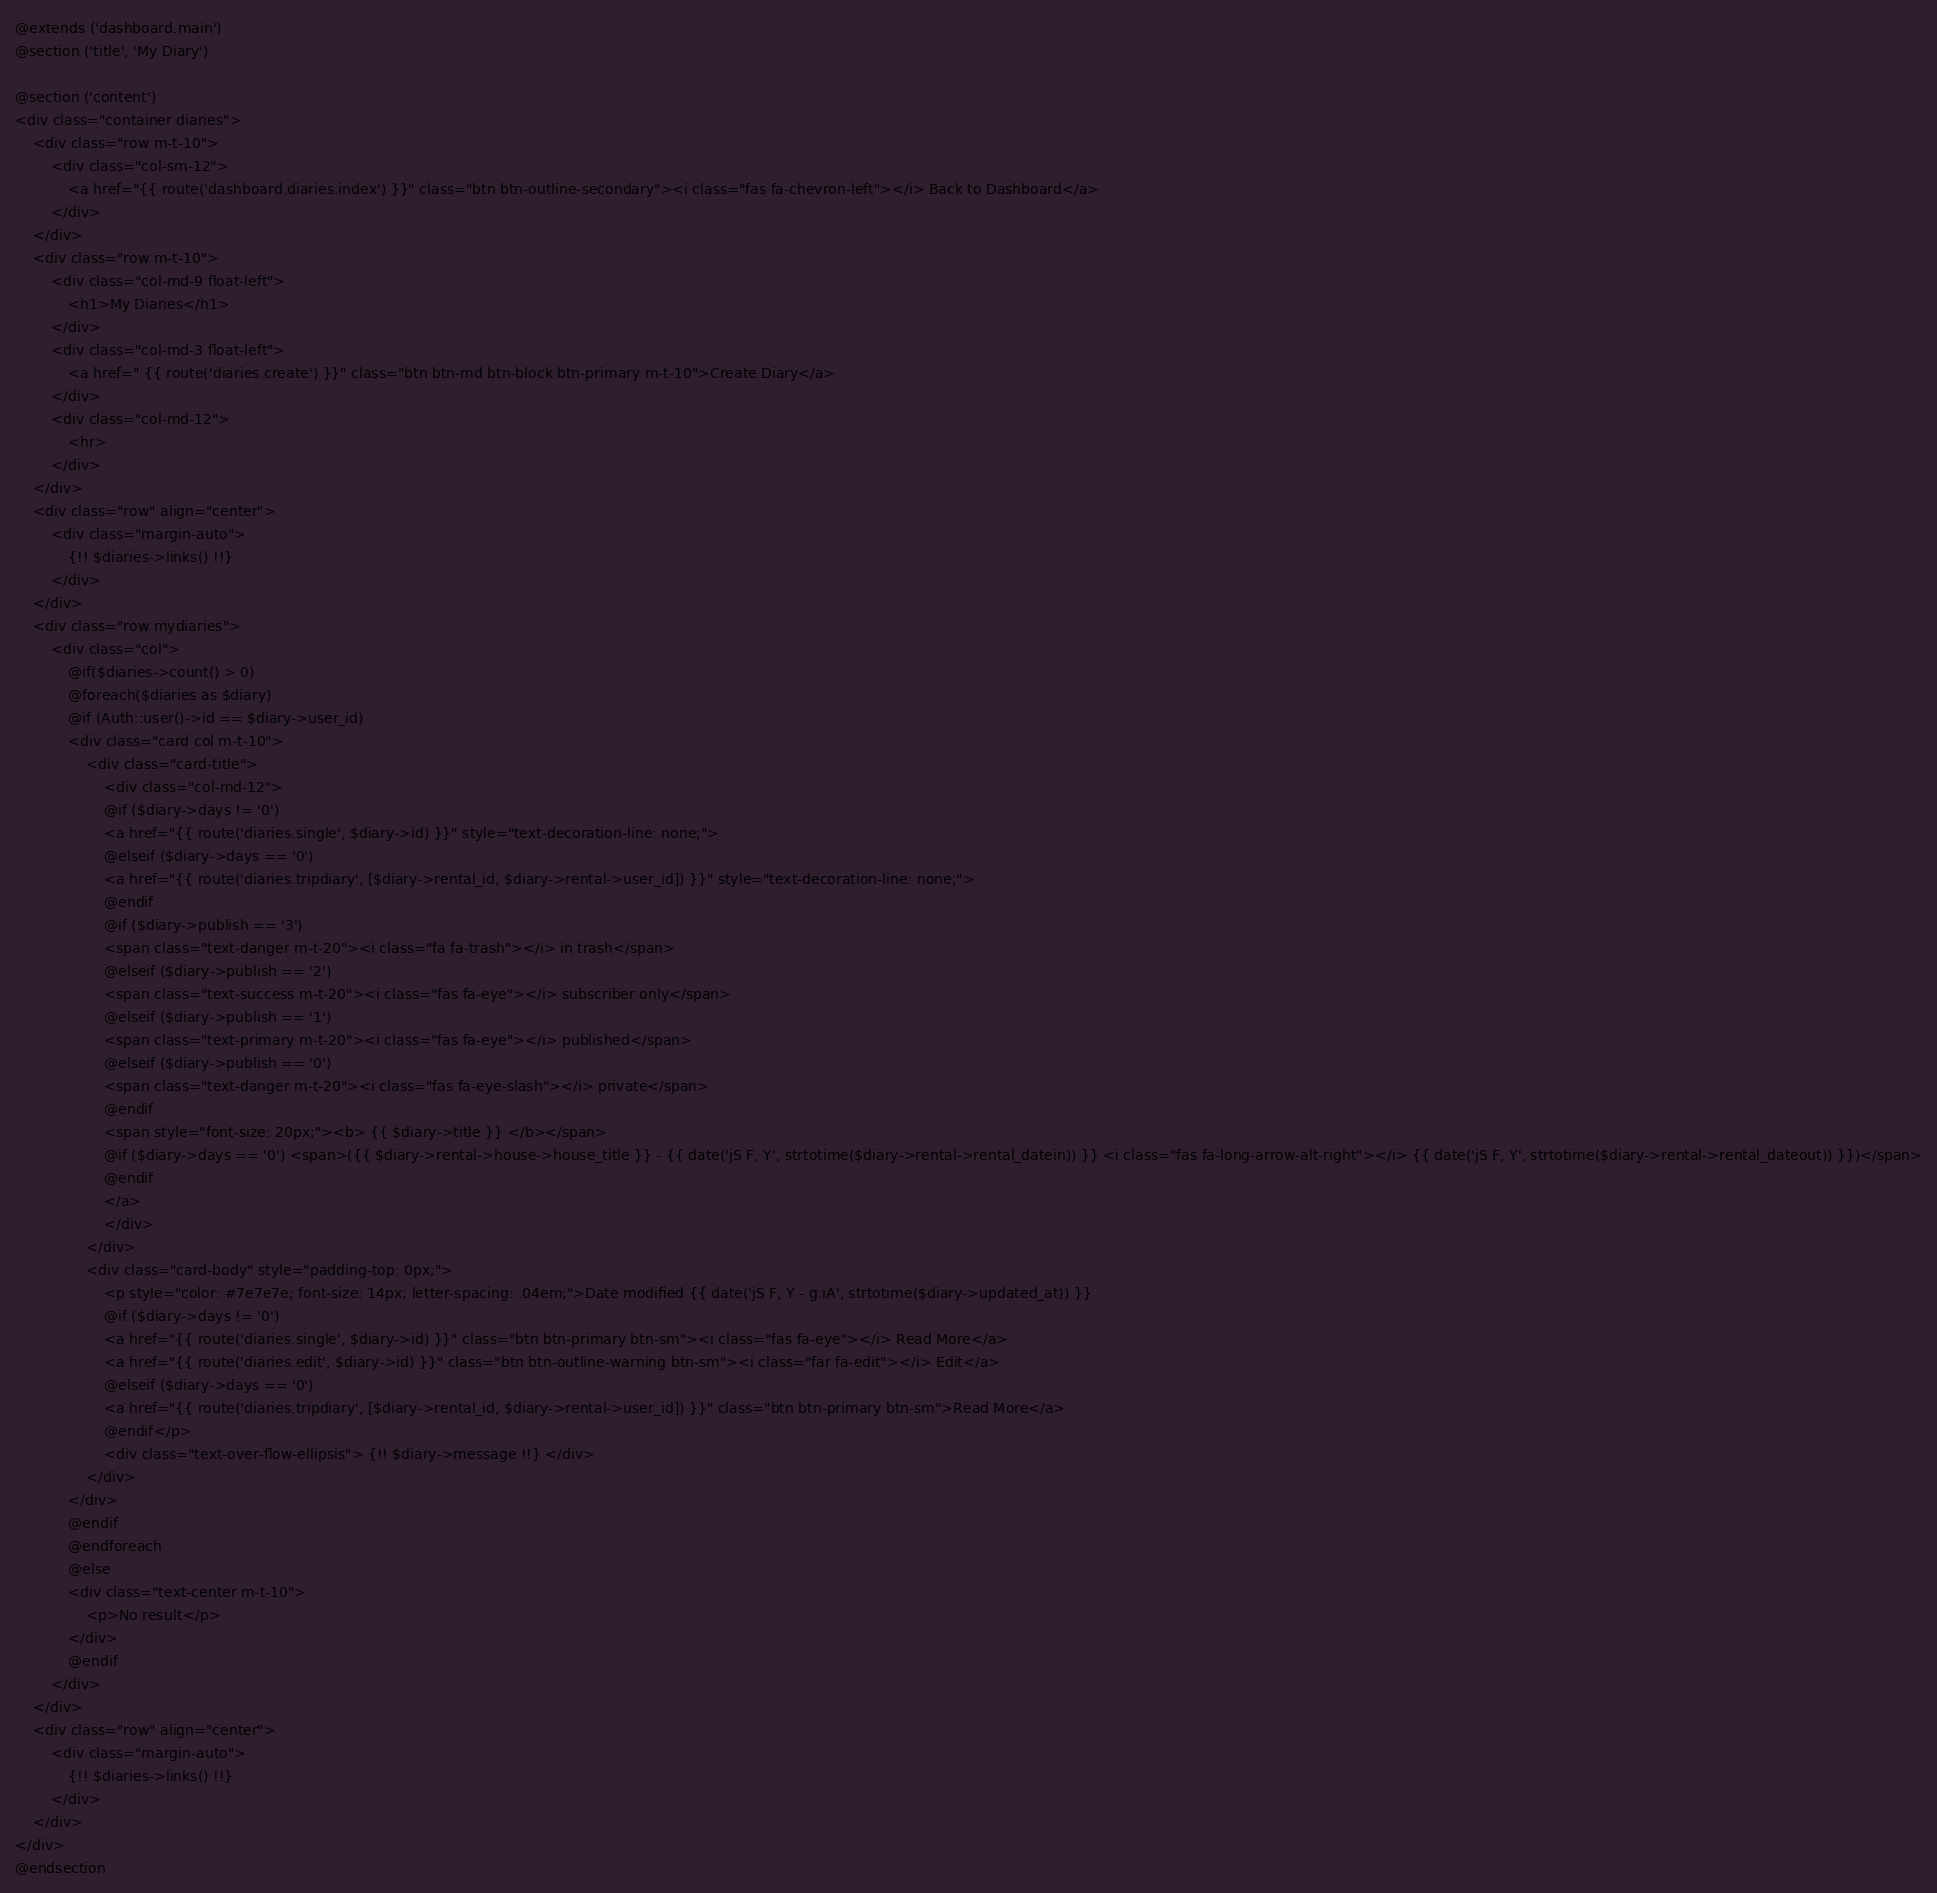<code> <loc_0><loc_0><loc_500><loc_500><_PHP_>@extends ('dashboard.main')
@section ('title', 'My Diary')

@section ('content')
<div class="container diaries">
	<div class="row m-t-10">
		<div class="col-sm-12">
			<a href="{{ route('dashboard.diaries.index') }}" class="btn btn-outline-secondary"><i class="fas fa-chevron-left"></i> Back to Dashboard</a>
		</div>
	</div>
	<div class="row m-t-10">
		<div class="col-md-9 float-left">
			<h1>My Diaries</h1>
		</div>
		<div class="col-md-3 float-left">
			<a href=" {{ route('diaries.create') }}" class="btn btn-md btn-block btn-primary m-t-10">Create Diary</a>
		</div>
		<div class="col-md-12">
			<hr>
		</div>
	</div>
	<div class="row" align="center">
		<div class="margin-auto">
			{!! $diaries->links() !!}
		</div>
	</div>
	<div class="row mydiaries">
		<div class="col">
			@if($diaries->count() > 0)
			@foreach($diaries as $diary)
			@if (Auth::user()->id == $diary->user_id)
			<div class="card col m-t-10">
				<div class="card-title">
					<div class="col-md-12">
					@if ($diary->days != '0')
					<a href="{{ route('diaries.single', $diary->id) }}" style="text-decoration-line: none;">
					@elseif ($diary->days == '0')
					<a href="{{ route('diaries.tripdiary', [$diary->rental_id, $diary->rental->user_id]) }}" style="text-decoration-line: none;">
					@endif
					@if ($diary->publish == '3')
					<span class="text-danger m-t-20"><i class="fa fa-trash"></i> in trash</span>
					@elseif ($diary->publish == '2')
					<span class="text-success m-t-20"><i class="fas fa-eye"></i> subscriber only</span>
					@elseif ($diary->publish == '1')
					<span class="text-primary m-t-20"><i class="fas fa-eye"></i> published</span>
					@elseif ($diary->publish == '0')
					<span class="text-danger m-t-20"><i class="fas fa-eye-slash"></i> private</span>
					@endif
					<span style="font-size: 20px;"><b> {{ $diary->title }} </b></span>
					@if ($diary->days == '0') <span>({{ $diary->rental->house->house_title }} - {{ date('jS F, Y', strtotime($diary->rental->rental_datein)) }} <i class="fas fa-long-arrow-alt-right"></i> {{ date('jS F, Y', strtotime($diary->rental->rental_dateout)) }})</span>
					@endif
					</a>
					</div>
				</div>
				<div class="card-body" style="padding-top: 0px;">
					<p style="color: #7e7e7e; font-size: 14px; letter-spacing: .04em;">Date modified {{ date('jS F, Y - g:iA', strtotime($diary->updated_at)) }}
					@if ($diary->days != '0')
					<a href="{{ route('diaries.single', $diary->id) }}" class="btn btn-primary btn-sm"><i class="fas fa-eye"></i> Read More</a>
					<a href="{{ route('diaries.edit', $diary->id) }}" class="btn btn-outline-warning btn-sm"><i class="far fa-edit"></i> Edit</a>
					@elseif ($diary->days == '0')
					<a href="{{ route('diaries.tripdiary', [$diary->rental_id, $diary->rental->user_id]) }}" class="btn btn-primary btn-sm">Read More</a>
					@endif</p>
					<div class="text-over-flow-ellipsis"> {!! $diary->message !!} </div>
				</div>
			</div>
			@endif
			@endforeach
			@else
			<div class="text-center m-t-10">
				<p>No result</p>
			</div>
			@endif
		</div>
	</div>
	<div class="row" align="center">
		<div class="margin-auto">
			{!! $diaries->links() !!}
		</div>
	</div>
</div>
@endsection
</code> 